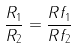Convert formula to latex. <formula><loc_0><loc_0><loc_500><loc_500>\frac { R _ { 1 } } { R _ { 2 } } = \frac { R f _ { 1 } } { R f _ { 2 } }</formula> 